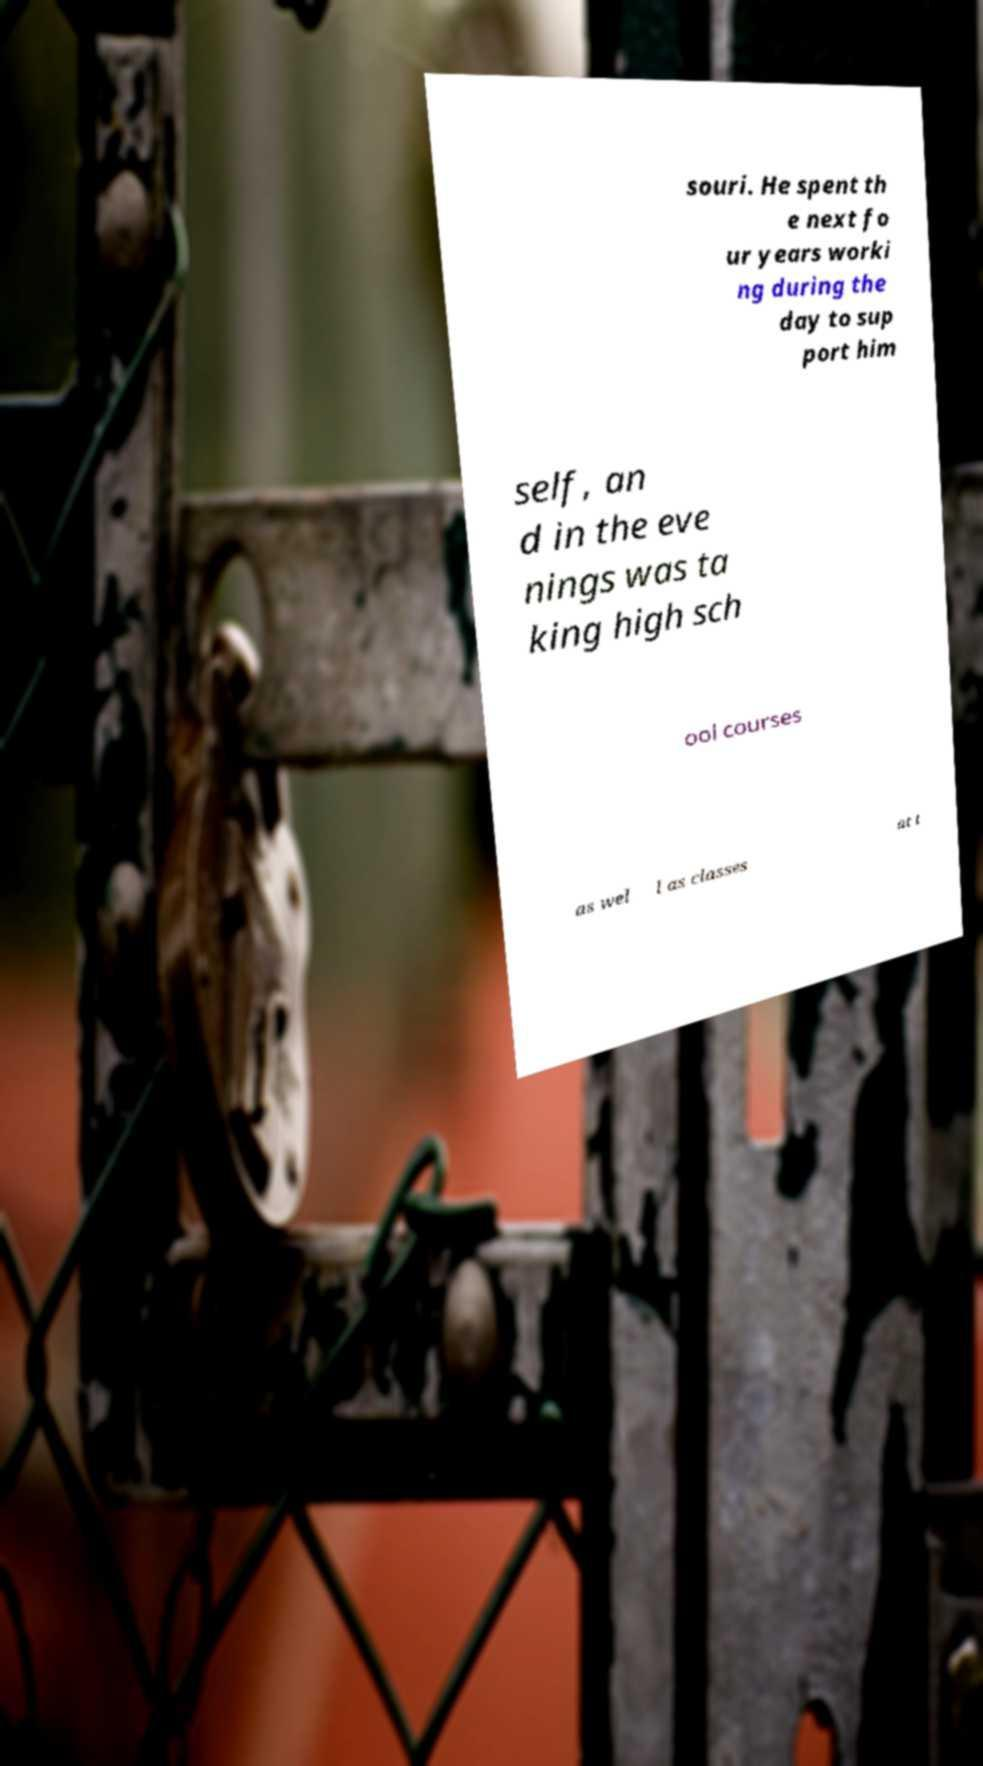Please identify and transcribe the text found in this image. souri. He spent th e next fo ur years worki ng during the day to sup port him self, an d in the eve nings was ta king high sch ool courses as wel l as classes at t 